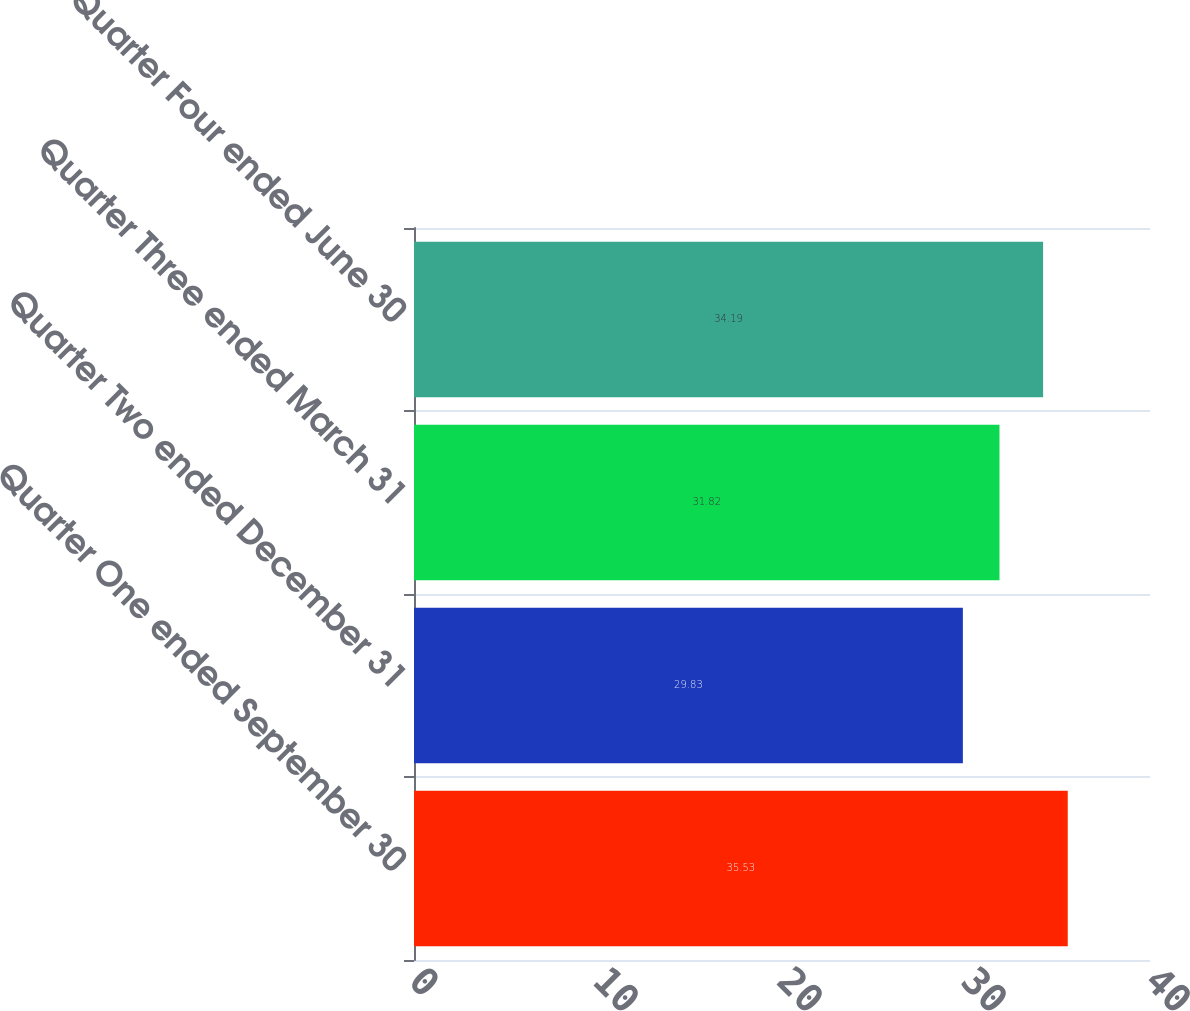<chart> <loc_0><loc_0><loc_500><loc_500><bar_chart><fcel>Quarter One ended September 30<fcel>Quarter Two ended December 31<fcel>Quarter Three ended March 31<fcel>Quarter Four ended June 30<nl><fcel>35.53<fcel>29.83<fcel>31.82<fcel>34.19<nl></chart> 